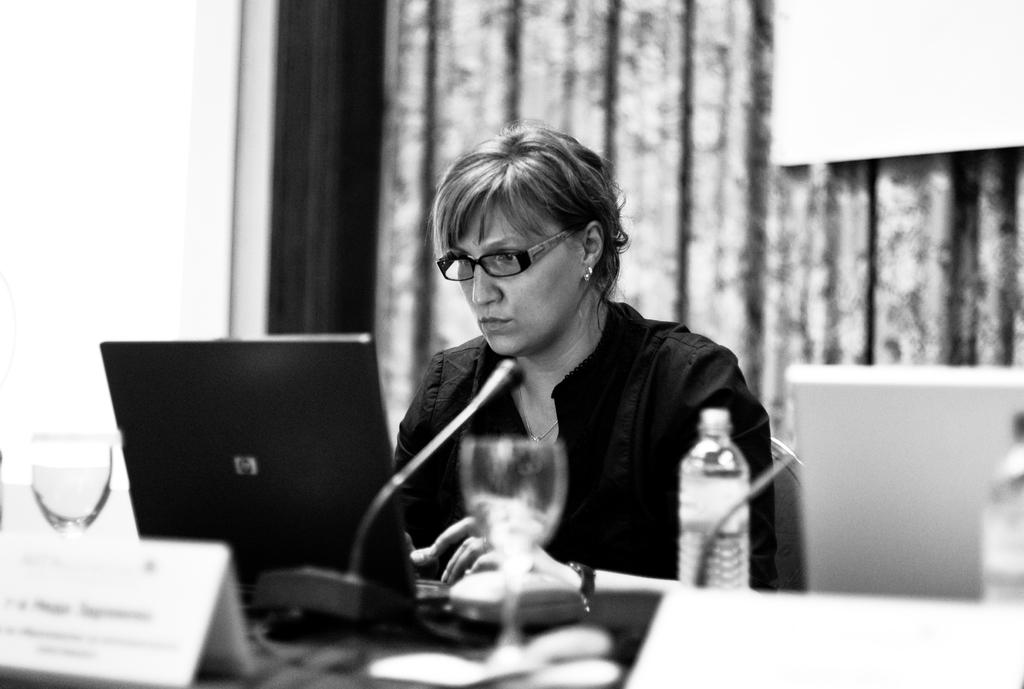What is the lady in the image doing? The lady is sitting on a chair in the image. What is in front of the lady? There is a table in front of the lady. What items can be seen on the table? There are mics, a laptop, a name plate, a glass, and bottles on the table. What can be seen in the background of the image? There are curtains in the background. What type of sweater is the lady wearing in the image? The lady is not wearing a sweater in the image; she is wearing a dress. Is there a cave visible in the background of the image? No, there is no cave present in the image; only curtains can be seen in the background. 